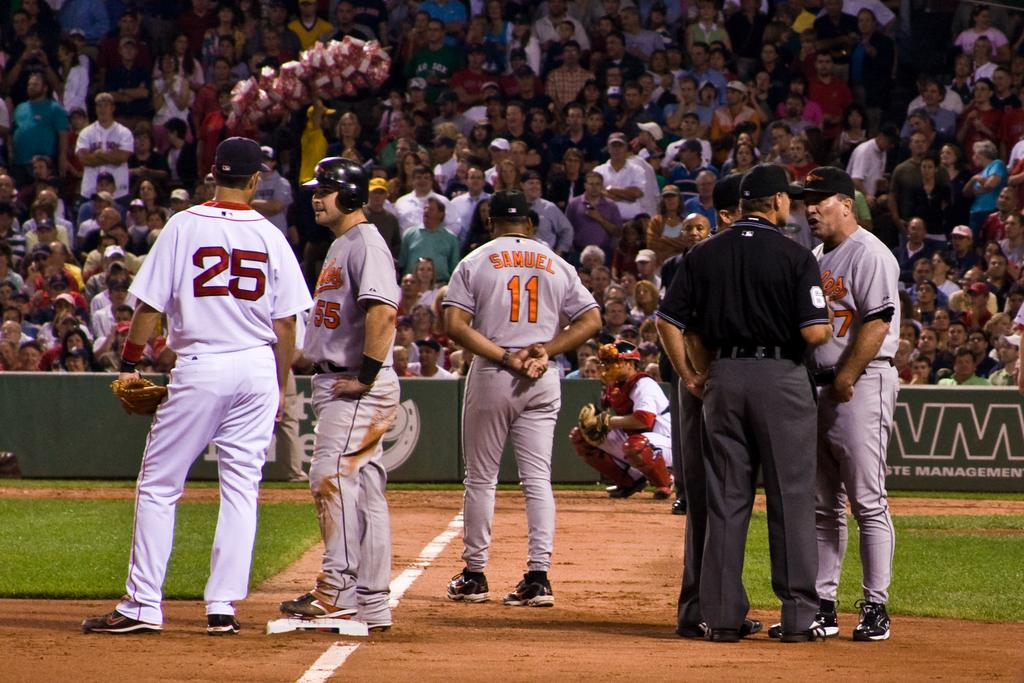<image>
Create a compact narrative representing the image presented. Baseball players including number 25 and 11 are on a baseball field. 